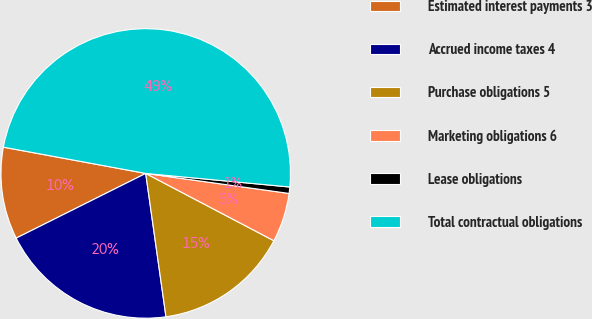Convert chart to OTSL. <chart><loc_0><loc_0><loc_500><loc_500><pie_chart><fcel>Estimated interest payments 3<fcel>Accrued income taxes 4<fcel>Purchase obligations 5<fcel>Marketing obligations 6<fcel>Lease obligations<fcel>Total contractual obligations<nl><fcel>10.28%<fcel>19.86%<fcel>15.07%<fcel>5.49%<fcel>0.71%<fcel>48.59%<nl></chart> 